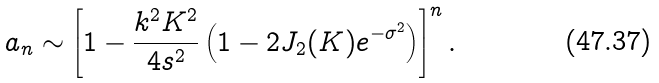Convert formula to latex. <formula><loc_0><loc_0><loc_500><loc_500>a _ { n } \sim \left [ 1 - \frac { k ^ { 2 } K ^ { 2 } } { 4 s ^ { 2 } } \left ( 1 - 2 J _ { 2 } ( K ) e ^ { - \sigma ^ { 2 } } \right ) \right ] ^ { n } .</formula> 